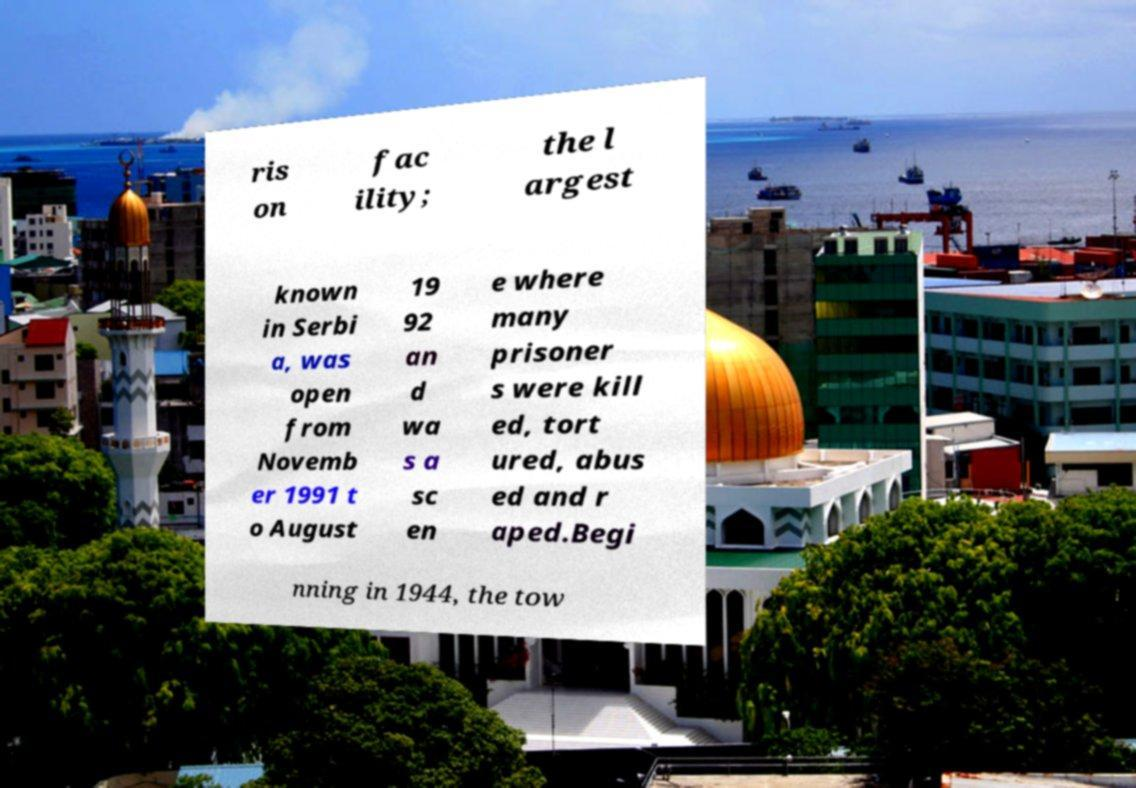Could you assist in decoding the text presented in this image and type it out clearly? ris on fac ility; the l argest known in Serbi a, was open from Novemb er 1991 t o August 19 92 an d wa s a sc en e where many prisoner s were kill ed, tort ured, abus ed and r aped.Begi nning in 1944, the tow 